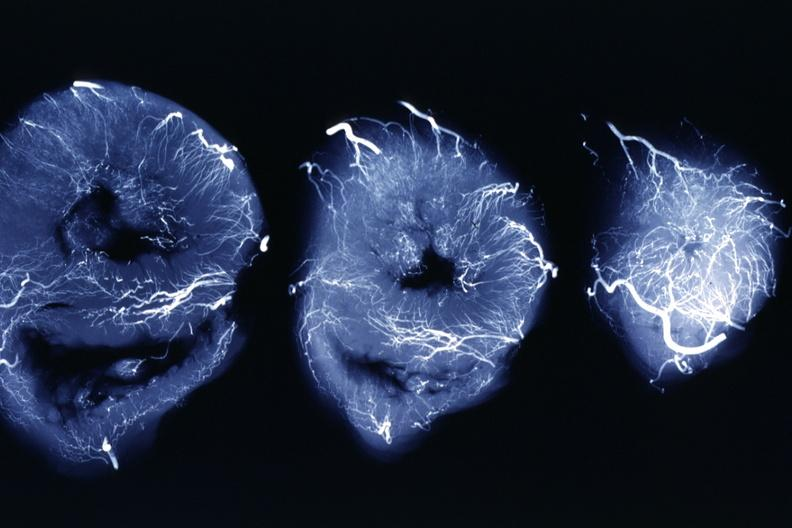what is present?
Answer the question using a single word or phrase. Cardiovascular 